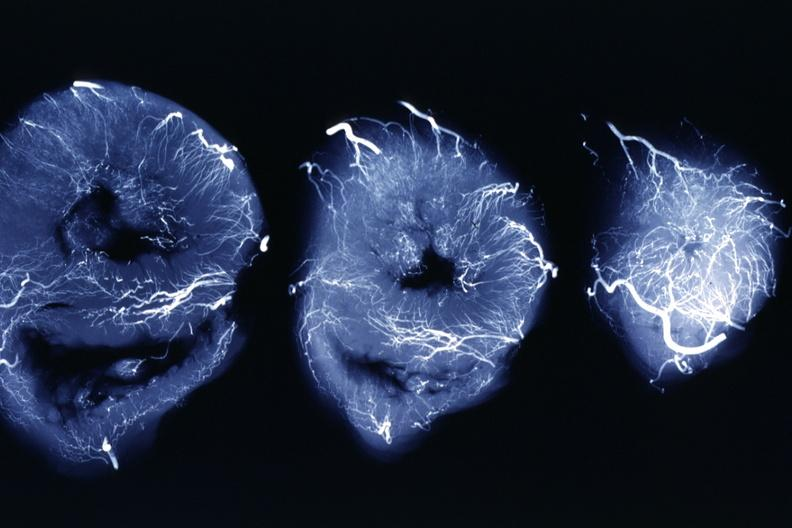what is present?
Answer the question using a single word or phrase. Cardiovascular 